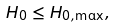Convert formula to latex. <formula><loc_0><loc_0><loc_500><loc_500>H _ { 0 } \leq H _ { 0 , \max } ,</formula> 